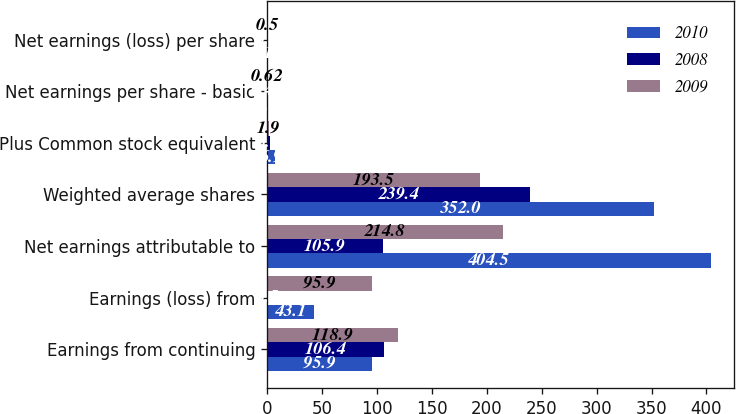<chart> <loc_0><loc_0><loc_500><loc_500><stacked_bar_chart><ecel><fcel>Earnings from continuing<fcel>Earnings (loss) from<fcel>Net earnings attributable to<fcel>Weighted average shares<fcel>Plus Common stock equivalent<fcel>Net earnings per share - basic<fcel>Net earnings (loss) per share<nl><fcel>2010<fcel>95.9<fcel>43.1<fcel>404.5<fcel>352<fcel>6.9<fcel>1.3<fcel>0.12<nl><fcel>2008<fcel>106.4<fcel>0.5<fcel>105.9<fcel>239.4<fcel>3<fcel>0.45<fcel>0<nl><fcel>2009<fcel>118.9<fcel>95.9<fcel>214.8<fcel>193.5<fcel>1.9<fcel>0.62<fcel>0.5<nl></chart> 